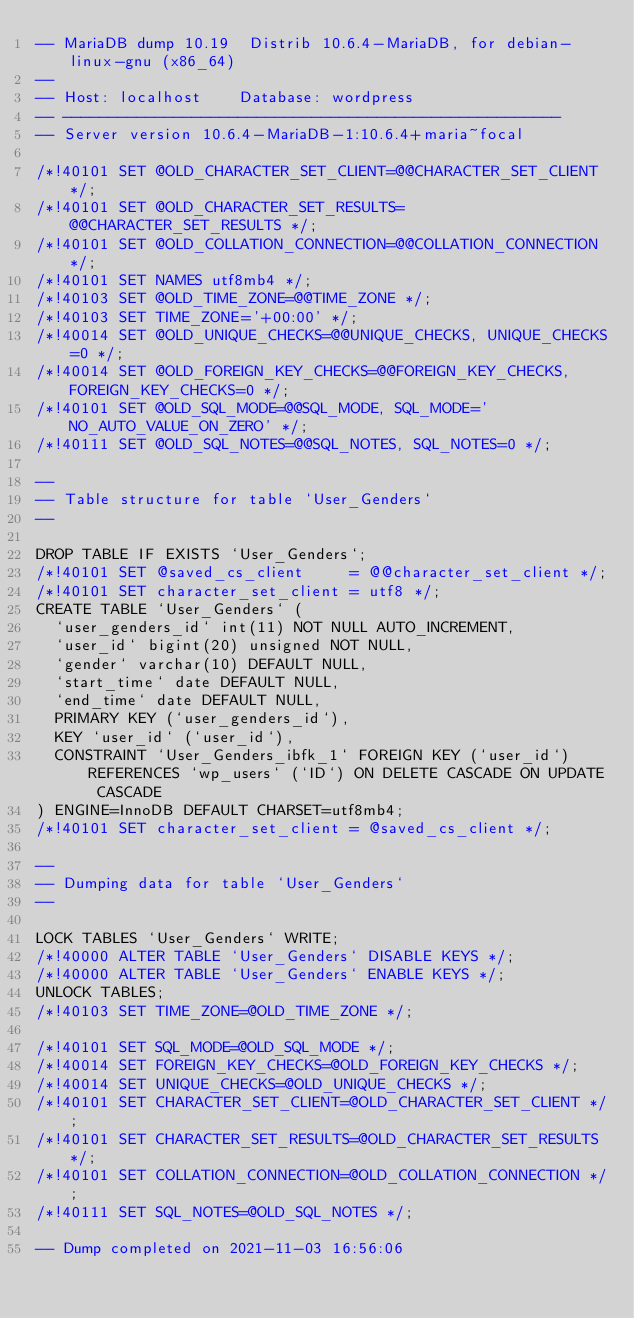Convert code to text. <code><loc_0><loc_0><loc_500><loc_500><_SQL_>-- MariaDB dump 10.19  Distrib 10.6.4-MariaDB, for debian-linux-gnu (x86_64)
--
-- Host: localhost    Database: wordpress
-- ------------------------------------------------------
-- Server version	10.6.4-MariaDB-1:10.6.4+maria~focal

/*!40101 SET @OLD_CHARACTER_SET_CLIENT=@@CHARACTER_SET_CLIENT */;
/*!40101 SET @OLD_CHARACTER_SET_RESULTS=@@CHARACTER_SET_RESULTS */;
/*!40101 SET @OLD_COLLATION_CONNECTION=@@COLLATION_CONNECTION */;
/*!40101 SET NAMES utf8mb4 */;
/*!40103 SET @OLD_TIME_ZONE=@@TIME_ZONE */;
/*!40103 SET TIME_ZONE='+00:00' */;
/*!40014 SET @OLD_UNIQUE_CHECKS=@@UNIQUE_CHECKS, UNIQUE_CHECKS=0 */;
/*!40014 SET @OLD_FOREIGN_KEY_CHECKS=@@FOREIGN_KEY_CHECKS, FOREIGN_KEY_CHECKS=0 */;
/*!40101 SET @OLD_SQL_MODE=@@SQL_MODE, SQL_MODE='NO_AUTO_VALUE_ON_ZERO' */;
/*!40111 SET @OLD_SQL_NOTES=@@SQL_NOTES, SQL_NOTES=0 */;

--
-- Table structure for table `User_Genders`
--

DROP TABLE IF EXISTS `User_Genders`;
/*!40101 SET @saved_cs_client     = @@character_set_client */;
/*!40101 SET character_set_client = utf8 */;
CREATE TABLE `User_Genders` (
  `user_genders_id` int(11) NOT NULL AUTO_INCREMENT,
  `user_id` bigint(20) unsigned NOT NULL,
  `gender` varchar(10) DEFAULT NULL,
  `start_time` date DEFAULT NULL,
  `end_time` date DEFAULT NULL,
  PRIMARY KEY (`user_genders_id`),
  KEY `user_id` (`user_id`),
  CONSTRAINT `User_Genders_ibfk_1` FOREIGN KEY (`user_id`) REFERENCES `wp_users` (`ID`) ON DELETE CASCADE ON UPDATE CASCADE
) ENGINE=InnoDB DEFAULT CHARSET=utf8mb4;
/*!40101 SET character_set_client = @saved_cs_client */;

--
-- Dumping data for table `User_Genders`
--

LOCK TABLES `User_Genders` WRITE;
/*!40000 ALTER TABLE `User_Genders` DISABLE KEYS */;
/*!40000 ALTER TABLE `User_Genders` ENABLE KEYS */;
UNLOCK TABLES;
/*!40103 SET TIME_ZONE=@OLD_TIME_ZONE */;

/*!40101 SET SQL_MODE=@OLD_SQL_MODE */;
/*!40014 SET FOREIGN_KEY_CHECKS=@OLD_FOREIGN_KEY_CHECKS */;
/*!40014 SET UNIQUE_CHECKS=@OLD_UNIQUE_CHECKS */;
/*!40101 SET CHARACTER_SET_CLIENT=@OLD_CHARACTER_SET_CLIENT */;
/*!40101 SET CHARACTER_SET_RESULTS=@OLD_CHARACTER_SET_RESULTS */;
/*!40101 SET COLLATION_CONNECTION=@OLD_COLLATION_CONNECTION */;
/*!40111 SET SQL_NOTES=@OLD_SQL_NOTES */;

-- Dump completed on 2021-11-03 16:56:06
</code> 